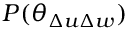<formula> <loc_0><loc_0><loc_500><loc_500>P ( \theta _ { \Delta u \Delta w } )</formula> 